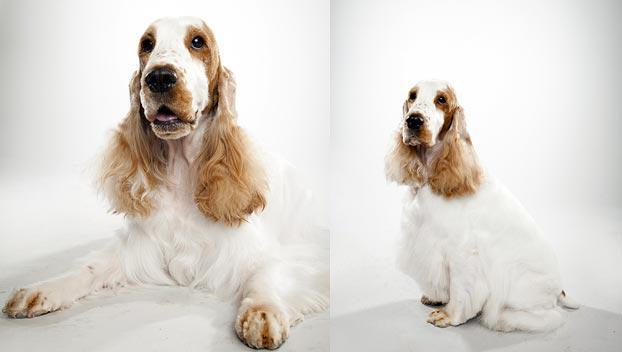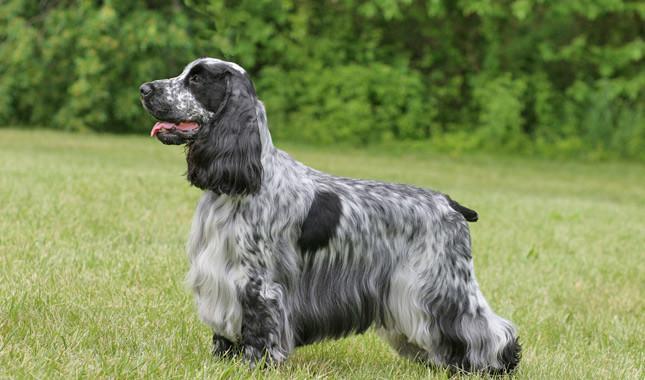The first image is the image on the left, the second image is the image on the right. Assess this claim about the two images: "Five spaniels are shown, in total.". Correct or not? Answer yes or no. No. The first image is the image on the left, the second image is the image on the right. Given the left and right images, does the statement "The right image contains exactly three dogs." hold true? Answer yes or no. No. 